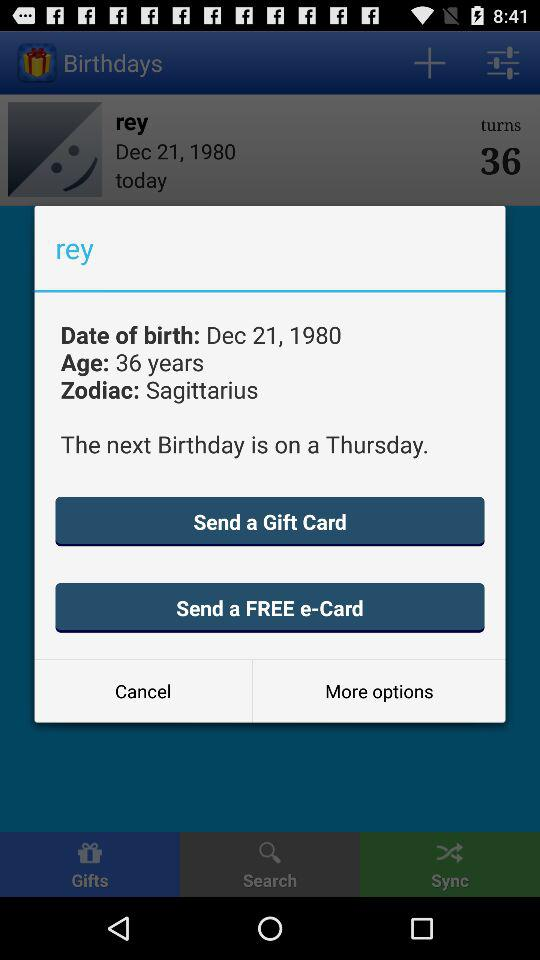The next birthday falls on what day? The day is Thursday. 